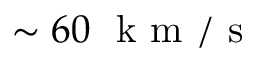<formula> <loc_0><loc_0><loc_500><loc_500>\sim 6 0 k m / s</formula> 